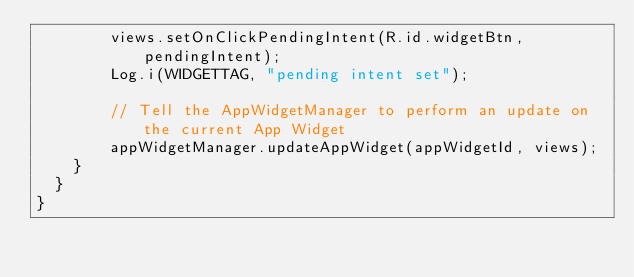<code> <loc_0><loc_0><loc_500><loc_500><_Java_>		    views.setOnClickPendingIntent(R.id.widgetBtn, pendingIntent);
		    Log.i(WIDGETTAG, "pending intent set");
		    
		    // Tell the AppWidgetManager to perform an update on the current App Widget
		    appWidgetManager.updateAppWidget(appWidgetId, views);
		}
	}	
}
</code> 